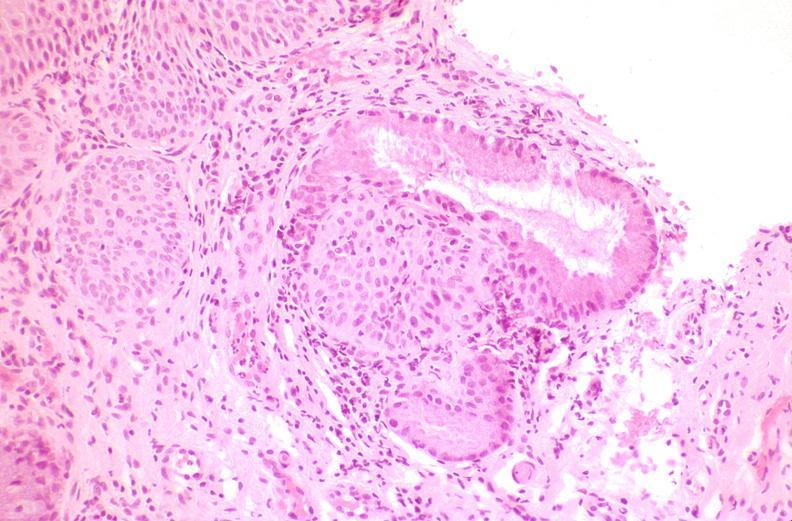s adenocarcinoma present?
Answer the question using a single word or phrase. No 